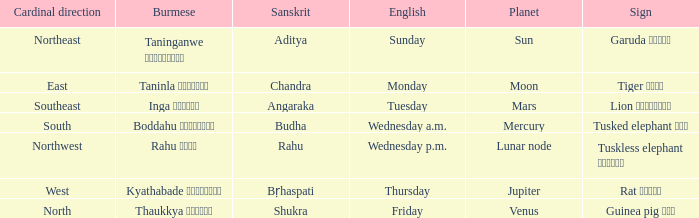How do you say thursday in burmese? Kyathabade ကြာသပတေး. 